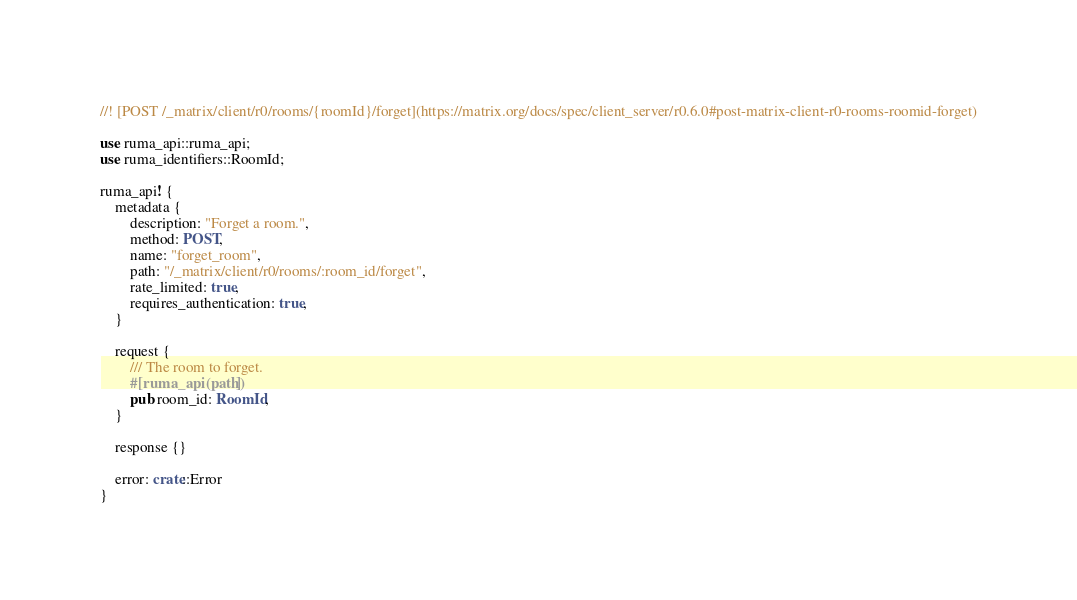Convert code to text. <code><loc_0><loc_0><loc_500><loc_500><_Rust_>//! [POST /_matrix/client/r0/rooms/{roomId}/forget](https://matrix.org/docs/spec/client_server/r0.6.0#post-matrix-client-r0-rooms-roomid-forget)

use ruma_api::ruma_api;
use ruma_identifiers::RoomId;

ruma_api! {
    metadata {
        description: "Forget a room.",
        method: POST,
        name: "forget_room",
        path: "/_matrix/client/r0/rooms/:room_id/forget",
        rate_limited: true,
        requires_authentication: true,
    }

    request {
        /// The room to forget.
        #[ruma_api(path)]
        pub room_id: RoomId,
    }

    response {}

    error: crate::Error
}
</code> 